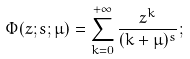<formula> <loc_0><loc_0><loc_500><loc_500>\Phi ( z ; s ; \mu ) = \sum _ { k = 0 } ^ { + \infty } \frac { z ^ { k } } { ( k + \mu ) ^ { s } } ;</formula> 